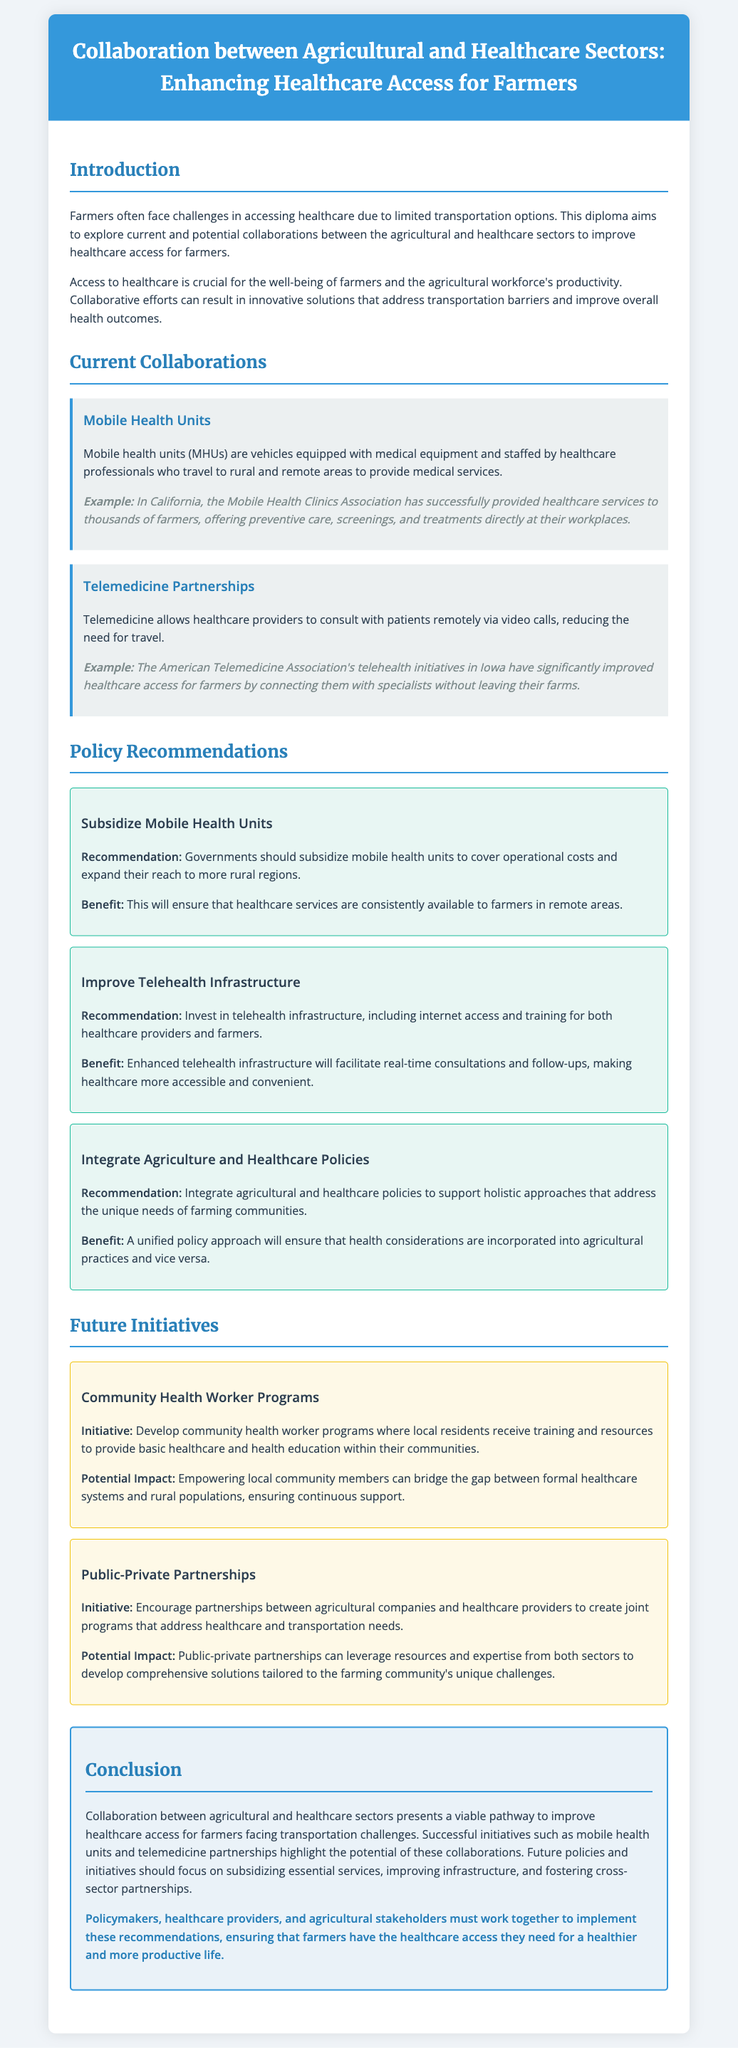What is the title of the diploma? The title of the diploma is located in the header section and indicates the subject matter.
Answer: Collaboration between Agricultural and Healthcare Sectors: Enhancing Healthcare Access for Farmers What is a successful example of mobile health units? The document provides a specific example illustrating the effectiveness of mobile health units in a state context.
Answer: Mobile Health Clinics Association in California What infrastructure improvement is recommended for telehealth? The document suggests specific improvements essential for enhancing telehealth services.
Answer: Internet access and training What initiative is proposed to empower local communities? The document shares a new initiative aimed at building capacity within rural areas to improve healthcare access.
Answer: Community Health Worker Programs What is one of the benefits of integrating agriculture and healthcare policies? The document discusses multiple benefits arising from policy integration to support farmers' needs.
Answer: Ensure health considerations are incorporated What type of recommendations does the diploma provide? The diploma categorizes its suggestions based on a specific rationale for improving healthcare access.
Answer: Policy recommendations What is the goal of public-private partnerships as mentioned? The document outlines the main purpose of forming these partnerships within the agricultural and healthcare context.
Answer: Address healthcare and transportation needs What is the overarching theme of the conclusion? The conclusion synthesizes the main points covered in the diploma and emphasizes a key objective.
Answer: Improve healthcare access for farmers 